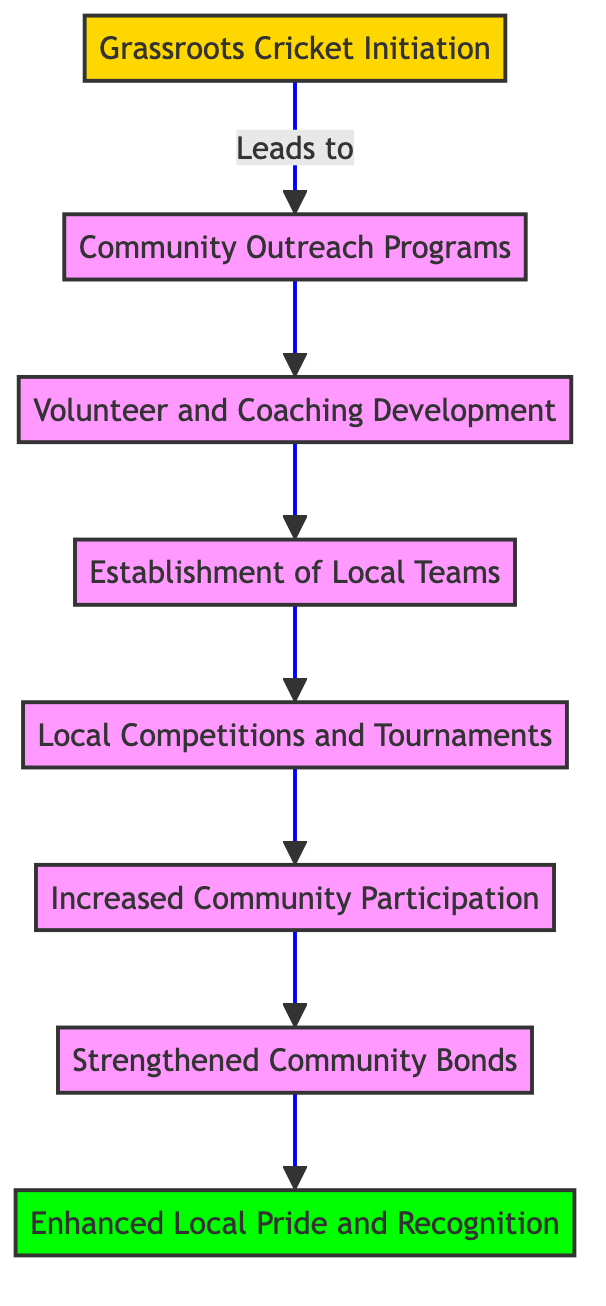What is the first step in the flow chart? The first step in the flow chart is "Grassroots Cricket Initiation," which is the foundation for all subsequent activities described in the diagram.
Answer: Grassroots Cricket Initiation How many total stages are there in the diagram? There are a total of eight stages represented in the diagram, each building on the previous stage to illustrate the flow of community engagement through grassroots cricket.
Answer: Eight What connects the "Local Competitions and Tournaments" to the next stage? The connection is represented by the arrow leading from "Local Competitions and Tournaments" to "Increased Community Participation," which indicates that local competitions contribute to an increase in community participation.
Answer: Increased Community Participation Which level describes the "Enhanced Local Pride and Recognition"? "Enhanced Local Pride and Recognition" is described at level 8, which is the final outcome in the flow of community engagement through grassroots cricket.
Answer: Level 8 What is the main purpose of the "Community Outreach Programs"? The main purpose of "Community Outreach Programs" is to engage residents through cricket workshops, training sessions, and awareness campaigns, creating opportunities for participation.
Answer: Engage residents What follows after "Volunteer and Coaching Development"? The next stage after "Volunteer and Coaching Development" is the "Establishment of Local Teams," indicating a progression from training volunteers to forming teams within the community.
Answer: Establishment of Local Teams What is the relationship between "Increased Community Participation" and "Strengthened Community Bonds"? "Increased Community Participation" leads to "Strengthened Community Bonds," illustrating that as community members participate more, their social connections and cohesion improve.
Answer: Increased Community Participation leads to Strengthened Community Bonds What is represented at the lowest level of the diagram? The lowest level of the diagram represents "Grassroots Cricket Initiation," which serves as the starting point for the entire engagement process involving cricket in the community.
Answer: Grassroots Cricket Initiation 